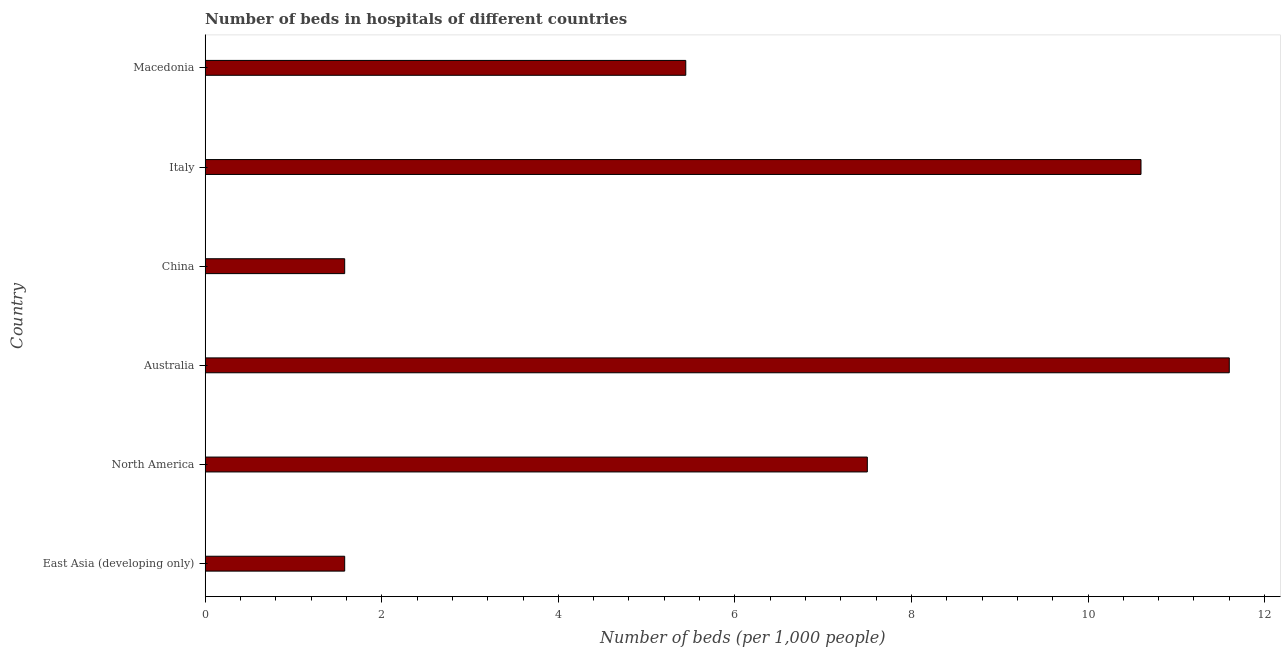Does the graph contain any zero values?
Your answer should be very brief. No. What is the title of the graph?
Your answer should be very brief. Number of beds in hospitals of different countries. What is the label or title of the X-axis?
Keep it short and to the point. Number of beds (per 1,0 people). What is the label or title of the Y-axis?
Give a very brief answer. Country. What is the number of hospital beds in Italy?
Your answer should be very brief. 10.6. Across all countries, what is the maximum number of hospital beds?
Provide a succinct answer. 11.6. Across all countries, what is the minimum number of hospital beds?
Keep it short and to the point. 1.58. In which country was the number of hospital beds maximum?
Make the answer very short. Australia. In which country was the number of hospital beds minimum?
Provide a succinct answer. East Asia (developing only). What is the sum of the number of hospital beds?
Provide a short and direct response. 38.3. What is the difference between the number of hospital beds in Italy and Macedonia?
Your answer should be compact. 5.16. What is the average number of hospital beds per country?
Provide a succinct answer. 6.38. What is the median number of hospital beds?
Give a very brief answer. 6.47. What is the ratio of the number of hospital beds in Australia to that in Macedonia?
Offer a terse response. 2.13. Is the sum of the number of hospital beds in China and Macedonia greater than the maximum number of hospital beds across all countries?
Provide a succinct answer. No. What is the difference between the highest and the lowest number of hospital beds?
Ensure brevity in your answer.  10.02. Are all the bars in the graph horizontal?
Your answer should be compact. Yes. What is the difference between two consecutive major ticks on the X-axis?
Offer a very short reply. 2. What is the Number of beds (per 1,000 people) in East Asia (developing only)?
Your answer should be compact. 1.58. What is the Number of beds (per 1,000 people) in North America?
Your answer should be very brief. 7.5. What is the Number of beds (per 1,000 people) of Australia?
Your answer should be compact. 11.6. What is the Number of beds (per 1,000 people) in China?
Your answer should be compact. 1.58. What is the Number of beds (per 1,000 people) in Italy?
Provide a short and direct response. 10.6. What is the Number of beds (per 1,000 people) in Macedonia?
Make the answer very short. 5.44. What is the difference between the Number of beds (per 1,000 people) in East Asia (developing only) and North America?
Make the answer very short. -5.92. What is the difference between the Number of beds (per 1,000 people) in East Asia (developing only) and Australia?
Ensure brevity in your answer.  -10.02. What is the difference between the Number of beds (per 1,000 people) in East Asia (developing only) and China?
Your response must be concise. 0. What is the difference between the Number of beds (per 1,000 people) in East Asia (developing only) and Italy?
Offer a terse response. -9.02. What is the difference between the Number of beds (per 1,000 people) in East Asia (developing only) and Macedonia?
Offer a terse response. -3.86. What is the difference between the Number of beds (per 1,000 people) in North America and Australia?
Offer a very short reply. -4.1. What is the difference between the Number of beds (per 1,000 people) in North America and China?
Offer a very short reply. 5.92. What is the difference between the Number of beds (per 1,000 people) in North America and Macedonia?
Provide a short and direct response. 2.06. What is the difference between the Number of beds (per 1,000 people) in Australia and China?
Your answer should be very brief. 10.02. What is the difference between the Number of beds (per 1,000 people) in Australia and Macedonia?
Ensure brevity in your answer.  6.16. What is the difference between the Number of beds (per 1,000 people) in China and Italy?
Give a very brief answer. -9.02. What is the difference between the Number of beds (per 1,000 people) in China and Macedonia?
Keep it short and to the point. -3.86. What is the difference between the Number of beds (per 1,000 people) in Italy and Macedonia?
Keep it short and to the point. 5.16. What is the ratio of the Number of beds (per 1,000 people) in East Asia (developing only) to that in North America?
Offer a very short reply. 0.21. What is the ratio of the Number of beds (per 1,000 people) in East Asia (developing only) to that in Australia?
Make the answer very short. 0.14. What is the ratio of the Number of beds (per 1,000 people) in East Asia (developing only) to that in Italy?
Your answer should be compact. 0.15. What is the ratio of the Number of beds (per 1,000 people) in East Asia (developing only) to that in Macedonia?
Offer a terse response. 0.29. What is the ratio of the Number of beds (per 1,000 people) in North America to that in Australia?
Keep it short and to the point. 0.65. What is the ratio of the Number of beds (per 1,000 people) in North America to that in China?
Offer a terse response. 4.75. What is the ratio of the Number of beds (per 1,000 people) in North America to that in Italy?
Keep it short and to the point. 0.71. What is the ratio of the Number of beds (per 1,000 people) in North America to that in Macedonia?
Your answer should be compact. 1.38. What is the ratio of the Number of beds (per 1,000 people) in Australia to that in China?
Offer a terse response. 7.34. What is the ratio of the Number of beds (per 1,000 people) in Australia to that in Italy?
Your answer should be compact. 1.09. What is the ratio of the Number of beds (per 1,000 people) in Australia to that in Macedonia?
Your answer should be compact. 2.13. What is the ratio of the Number of beds (per 1,000 people) in China to that in Italy?
Your response must be concise. 0.15. What is the ratio of the Number of beds (per 1,000 people) in China to that in Macedonia?
Offer a very short reply. 0.29. What is the ratio of the Number of beds (per 1,000 people) in Italy to that in Macedonia?
Your answer should be compact. 1.95. 